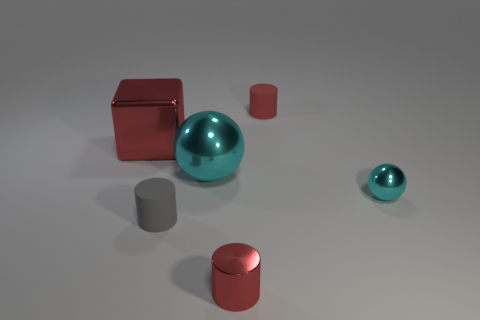Subtract all brown cubes. How many red cylinders are left? 2 Subtract all tiny red cylinders. How many cylinders are left? 1 Add 4 blocks. How many objects exist? 10 Subtract all balls. How many objects are left? 4 Add 4 big red shiny things. How many big red shiny things are left? 5 Add 4 tiny gray matte things. How many tiny gray matte things exist? 5 Subtract 0 yellow blocks. How many objects are left? 6 Subtract all big green matte things. Subtract all gray rubber objects. How many objects are left? 5 